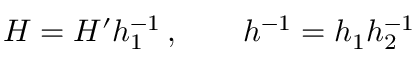Convert formula to latex. <formula><loc_0><loc_0><loc_500><loc_500>H = H ^ { \prime } h _ { 1 } ^ { - 1 } \, , \quad h ^ { - 1 } = h _ { 1 } h _ { 2 } ^ { - 1 }</formula> 